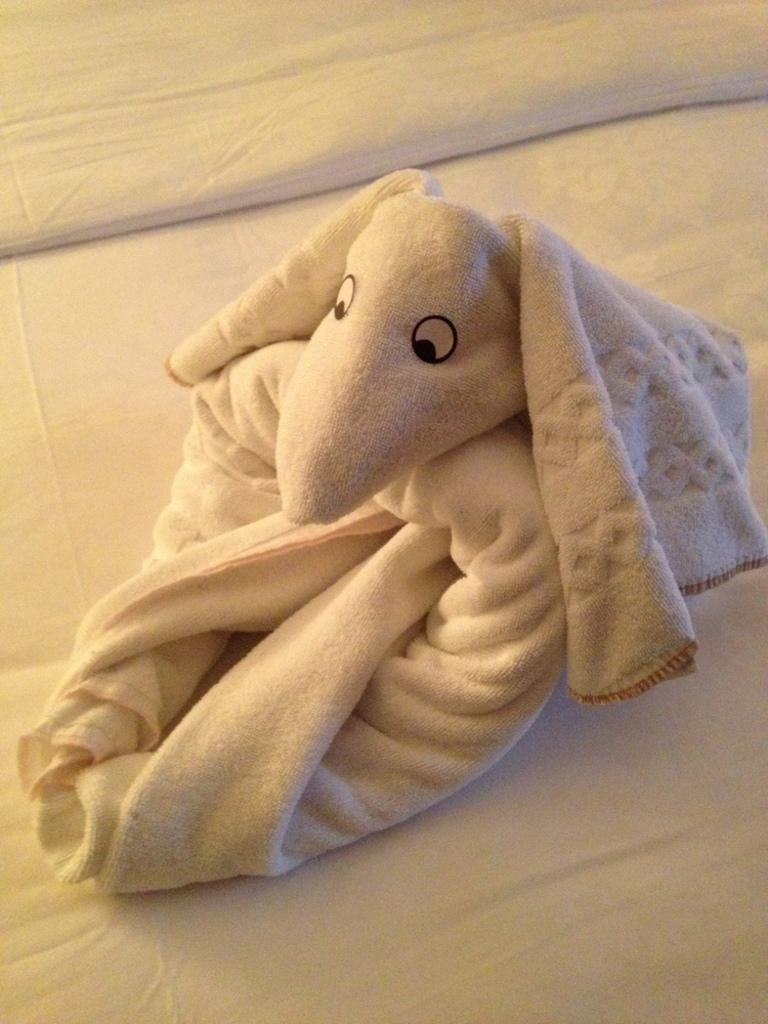What type of fabric is present in the image? There is a towel and a blanket in the image. What piece of furniture is visible in the image? There is a bed in the image. What type of spot can be seen on the blanket in the image? There is no spot visible on the blanket in the image. 